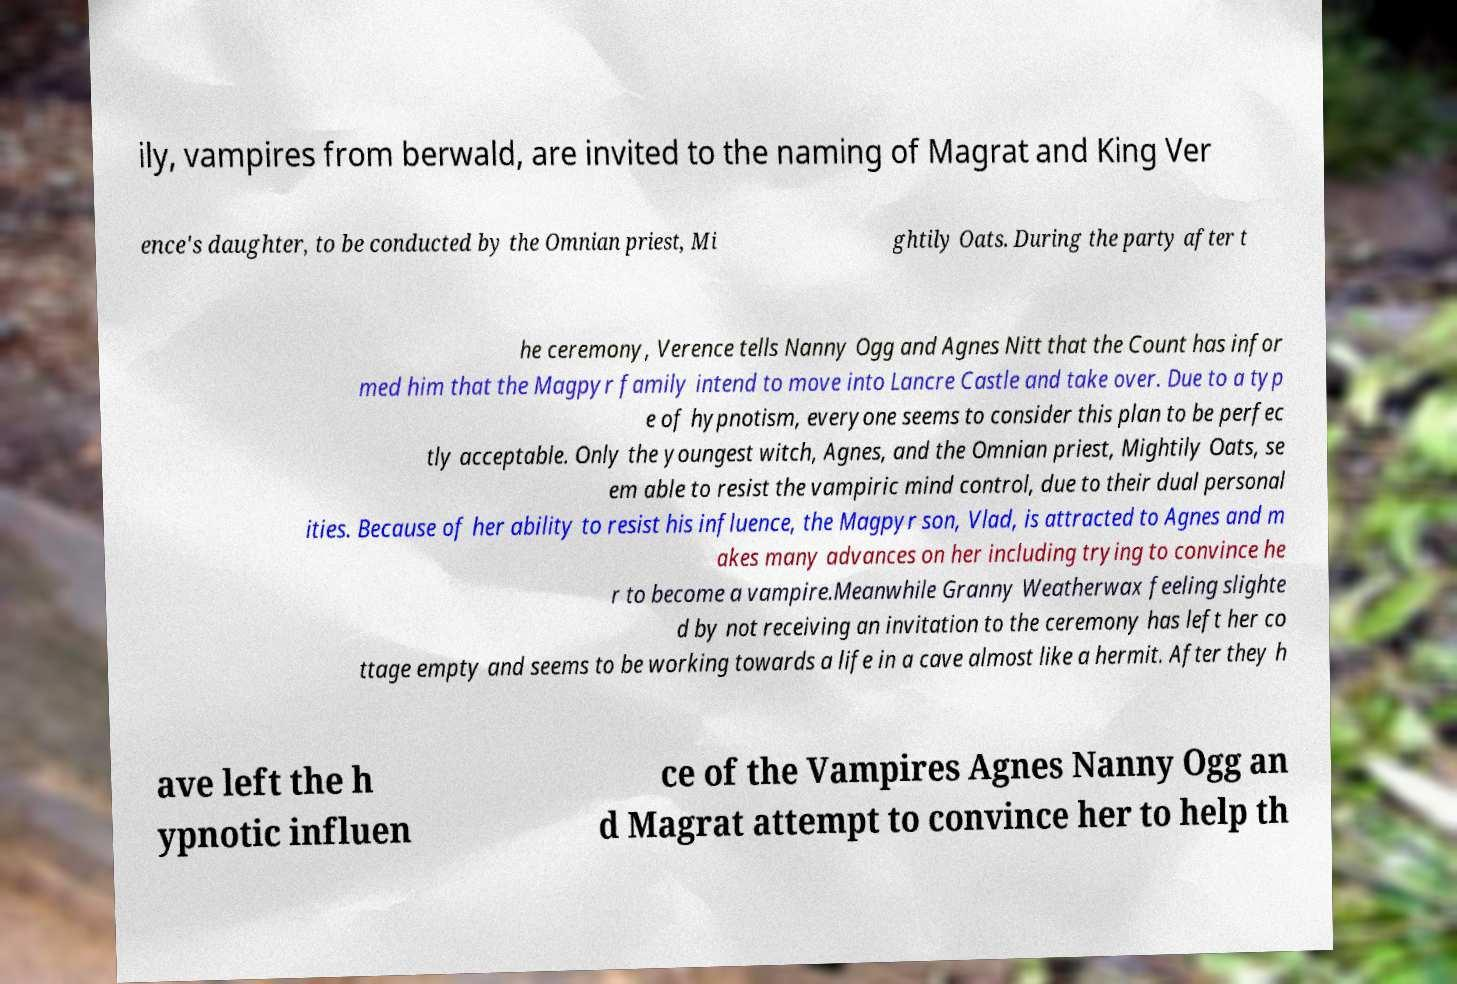Please identify and transcribe the text found in this image. ily, vampires from berwald, are invited to the naming of Magrat and King Ver ence's daughter, to be conducted by the Omnian priest, Mi ghtily Oats. During the party after t he ceremony, Verence tells Nanny Ogg and Agnes Nitt that the Count has infor med him that the Magpyr family intend to move into Lancre Castle and take over. Due to a typ e of hypnotism, everyone seems to consider this plan to be perfec tly acceptable. Only the youngest witch, Agnes, and the Omnian priest, Mightily Oats, se em able to resist the vampiric mind control, due to their dual personal ities. Because of her ability to resist his influence, the Magpyr son, Vlad, is attracted to Agnes and m akes many advances on her including trying to convince he r to become a vampire.Meanwhile Granny Weatherwax feeling slighte d by not receiving an invitation to the ceremony has left her co ttage empty and seems to be working towards a life in a cave almost like a hermit. After they h ave left the h ypnotic influen ce of the Vampires Agnes Nanny Ogg an d Magrat attempt to convince her to help th 